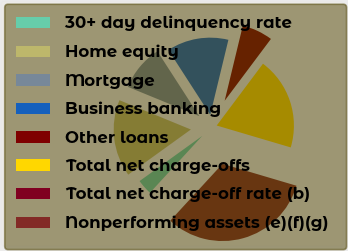Convert chart to OTSL. <chart><loc_0><loc_0><loc_500><loc_500><pie_chart><fcel>30+ day delinquency rate<fcel>Home equity<fcel>Mortgage<fcel>Business banking<fcel>Other loans<fcel>Total net charge-offs<fcel>Total net charge-off rate (b)<fcel>Nonperforming assets (e)(f)(g)<nl><fcel>3.23%<fcel>16.13%<fcel>9.68%<fcel>12.9%<fcel>6.45%<fcel>19.35%<fcel>0.0%<fcel>32.25%<nl></chart> 